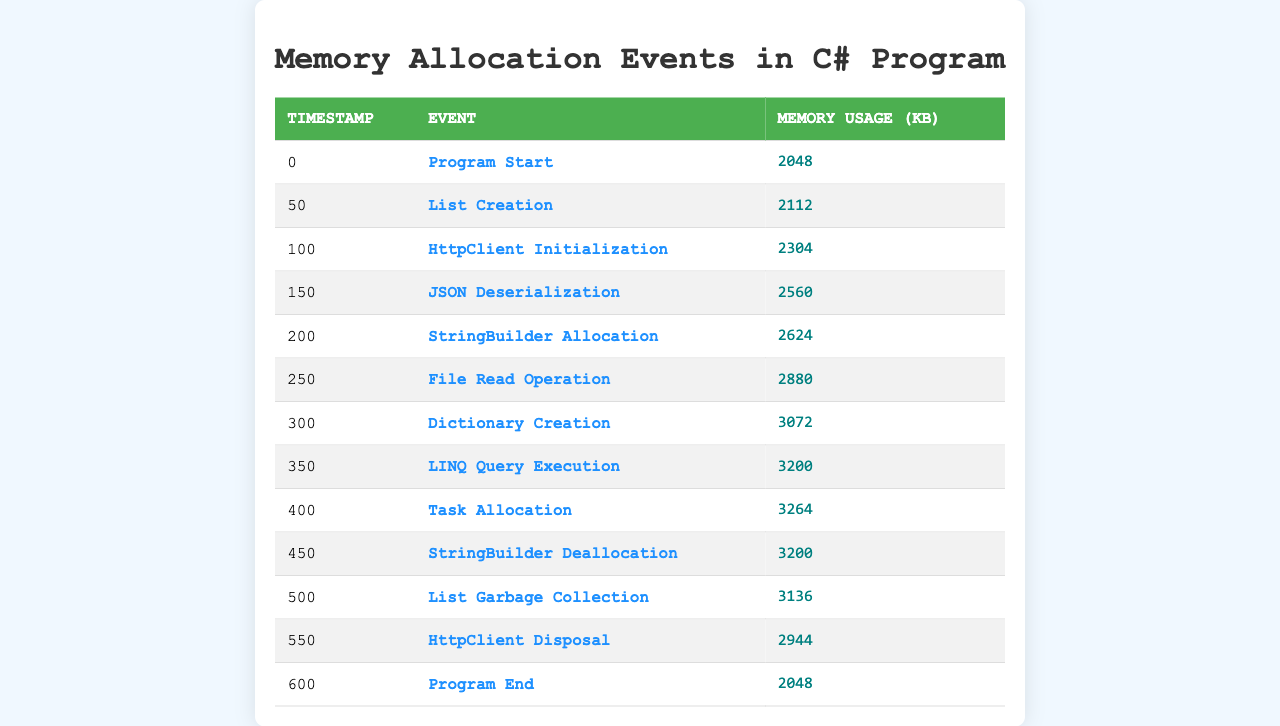What is the memory usage at program start? The first entry in the table shows the event "Program Start" with a memory usage of 2048 KB.
Answer: 2048 KB What event occurs right after the "HttpClient Initialization"? Looking at the table, the event following "HttpClient Initialization" at timestamp 100 is "JSON Deserialization" at timestamp 150.
Answer: JSON Deserialization How much memory is used after the "List<int> Creation"? The memory usage after "List<int> Creation" at timestamp 50 is 2112 KB. Checking the next event, "HttpClient Initialization" at timestamp 100, it shows 2304 KB. Therefore, the difference in memory usage is 2304 KB - 2112 KB = 192 KB.
Answer: 192 KB Was there any memory deallocation event? Reviewing the table, there are two events indicative of deallocation: "StringBuilder Deallocation" and "List<int> Garbage Collection." Therefore, the answer is yes.
Answer: Yes What is the total memory usage increase from program start to the end? The program starts with a memory usage of 2048 KB and ends with 2048 KB as well. Therefore, the total increase is 2048 KB (end) - 2048 KB (start) = 0 KB.
Answer: 0 KB How many events had a memory usage of more than 3000 KB? Checking the memory usage values, they are above 3000 KB during the events: "Dictionary<string, object> Creation," "LINQ Query Execution," and "Task<string> Allocation." There are 3 events in total.
Answer: 3 What is the memory usage during the "File Read Operation"? Referring to the table, during the "File Read Operation" at timestamp 250, the memory usage is 2880 KB.
Answer: 2880 KB Which event caused the largest memory allocation based on the changes between consecutive events? By analyzing the differences: 
- "Json Deserialization" to "StringBuilder Allocation": 2560 KB - 2304 KB = 256 KB
- "File Read Operation" to "Dictionary<string, object> Creation": 3072 KB - 2880 KB = 192 KB
- "Dictionary<string, object> Creation" to "LINQ Query Execution": 3200 KB - 3072 KB = 128 KB
The largest allocation is 256 KB from "HttpClient Initialization" to "JSON Deserialization."
Answer: JSON Deserialization What was the memory usage before the "HttpClient Disposal"? The memory usage just before "HttpClient Disposal" is from the previous event, which is at timestamp 550; it shows a memory usage of 2944 KB.
Answer: 2944 KB How much memory was freed after "StringBuilder Deallocation"? The "StringBuilder Deallocation" occurs at timestamp 450 with a usage of 3200 KB, and the next event "List<int> Garbage Collection" at timestamp 500 shows 3136 KB. The freed memory is 3200 KB - 3136 KB = 64 KB.
Answer: 64 KB 